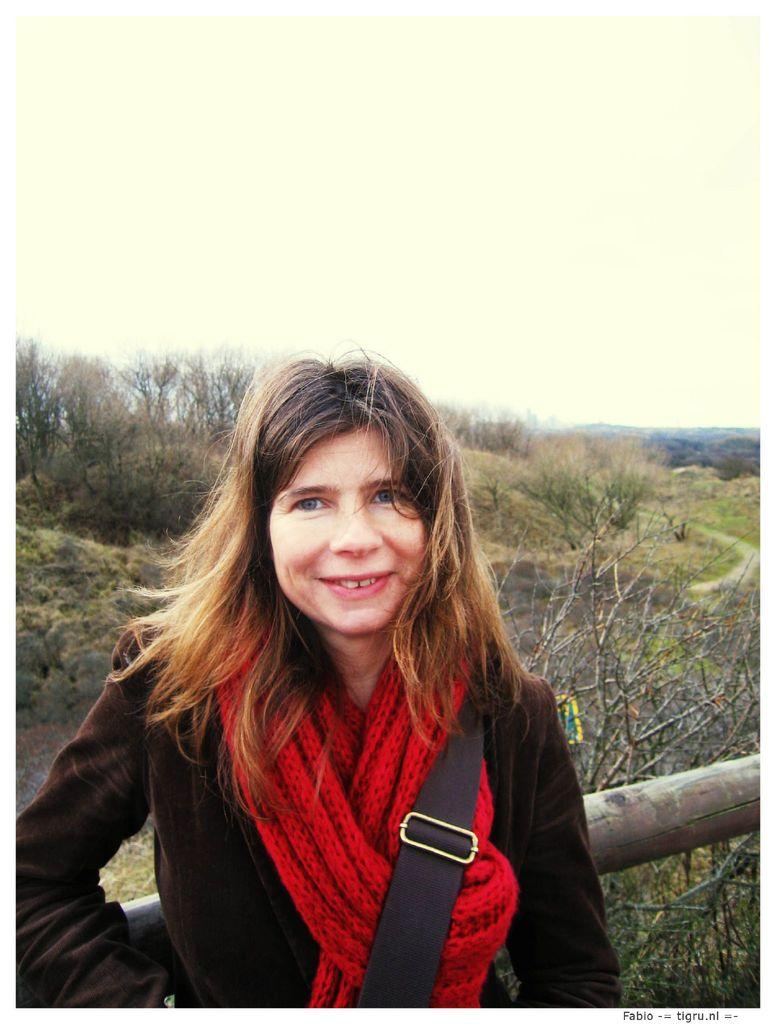What is the main subject in the foreground of the image? There is a woman in the foreground of the image. What is the woman wearing on her body? The woman is wearing a bag and a red scarf. How is the woman positioned in the image? The woman is standing by leaning on a wood. What can be seen in the background of the image? There are trees, a path, and the sky visible in the background of the image. What type of fruit is hanging from the chain in the image? There is no chain or fruit present in the image. What show is the woman attending in the image? There is no indication in the image that the woman is attending a show. 